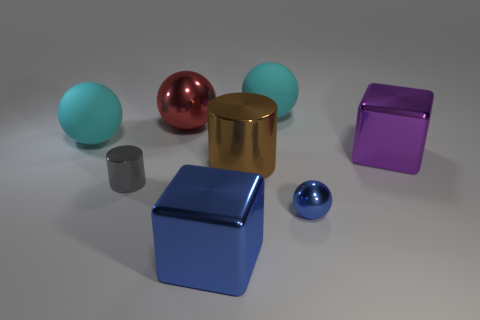Subtract all blue shiny balls. How many balls are left? 3 Subtract all brown cylinders. How many cylinders are left? 1 Add 1 cylinders. How many objects exist? 9 Subtract 1 cubes. How many cubes are left? 1 Subtract all cylinders. How many objects are left? 6 Subtract all blue cubes. How many cyan spheres are left? 2 Add 1 large rubber things. How many large rubber things exist? 3 Subtract 1 red spheres. How many objects are left? 7 Subtract all yellow spheres. Subtract all cyan cylinders. How many spheres are left? 4 Subtract all big rubber things. Subtract all big brown cylinders. How many objects are left? 5 